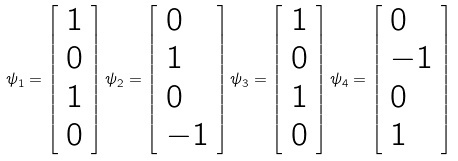Convert formula to latex. <formula><loc_0><loc_0><loc_500><loc_500>\psi _ { 1 } = \left [ \begin{array} { l l } 1 \\ 0 \\ 1 \\ 0 \end{array} \right ] \psi _ { 2 } = \left [ \begin{array} { l l } 0 \\ 1 \\ 0 \\ - 1 \end{array} \right ] \psi _ { 3 } = \left [ \begin{array} { l l } 1 \\ 0 \\ 1 \\ 0 \end{array} \right ] \psi _ { 4 } = \left [ \begin{array} { l l } 0 \\ - 1 \\ 0 \\ 1 \end{array} \right ]</formula> 